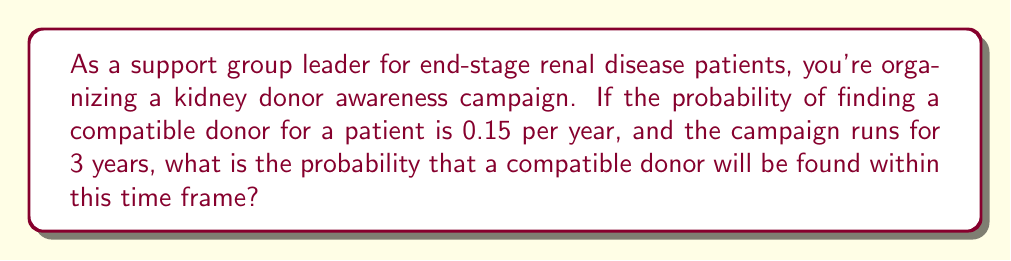What is the answer to this math problem? Let's approach this step-by-step:

1) First, we need to understand what the question is asking. We're looking for the probability of an event occurring at least once over a 3-year period, given an annual probability.

2) It's often easier to calculate the probability of an event not occurring, then subtract that from 1 to get the probability of it occurring.

3) The probability of not finding a compatible donor in one year is:
   $1 - 0.15 = 0.85$

4) For the event to not occur over 3 years, it must not occur in year 1 AND not occur in year 2 AND not occur in year 3. Assuming independence, we multiply these probabilities:
   $0.85 \times 0.85 \times 0.85 = 0.85^3 \approx 0.614125$

5) This 0.614125 is the probability of not finding a donor over the 3-year period.

6) Therefore, the probability of finding a donor within the 3-year period is:
   $1 - 0.614125 = 0.385875$

7) We can express this as a percentage: $0.385875 \times 100\% \approx 38.59\%$

Thus, there is approximately a 38.59% chance of finding a compatible donor within the 3-year campaign period.
Answer: $1 - 0.85^3 \approx 0.3859$ or $38.59\%$ 